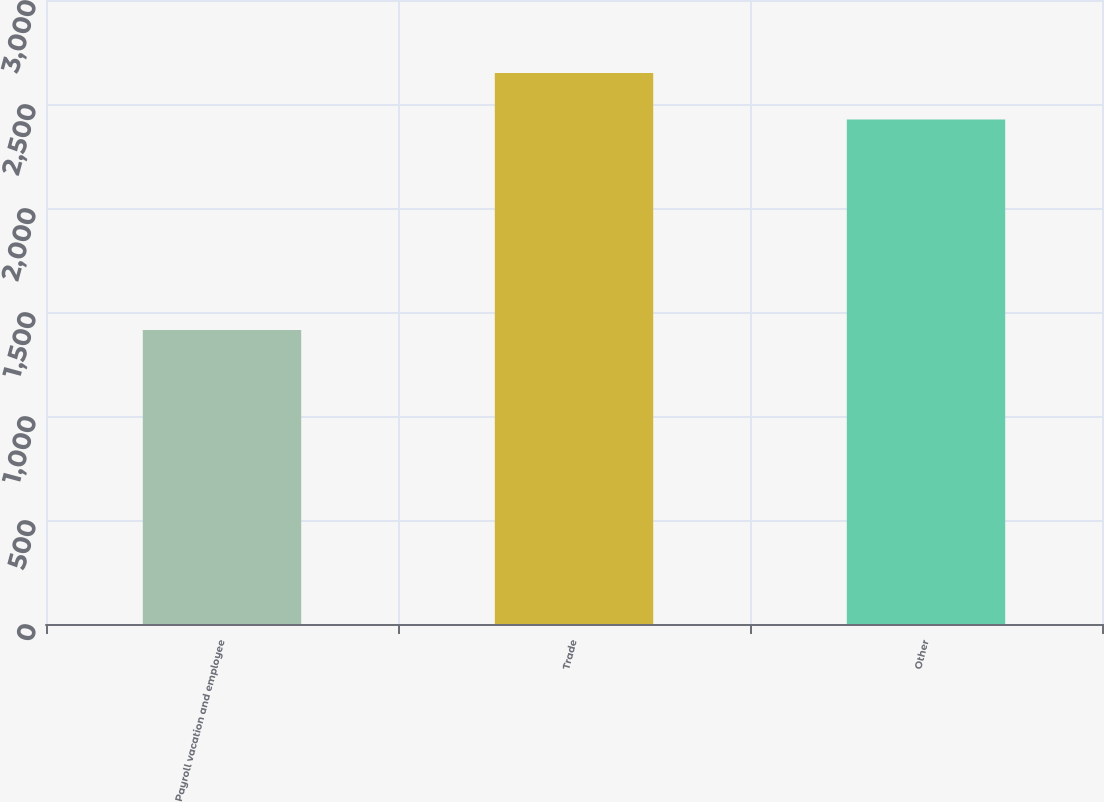Convert chart to OTSL. <chart><loc_0><loc_0><loc_500><loc_500><bar_chart><fcel>Payroll vacation and employee<fcel>Trade<fcel>Other<nl><fcel>1414<fcel>2649<fcel>2425<nl></chart> 